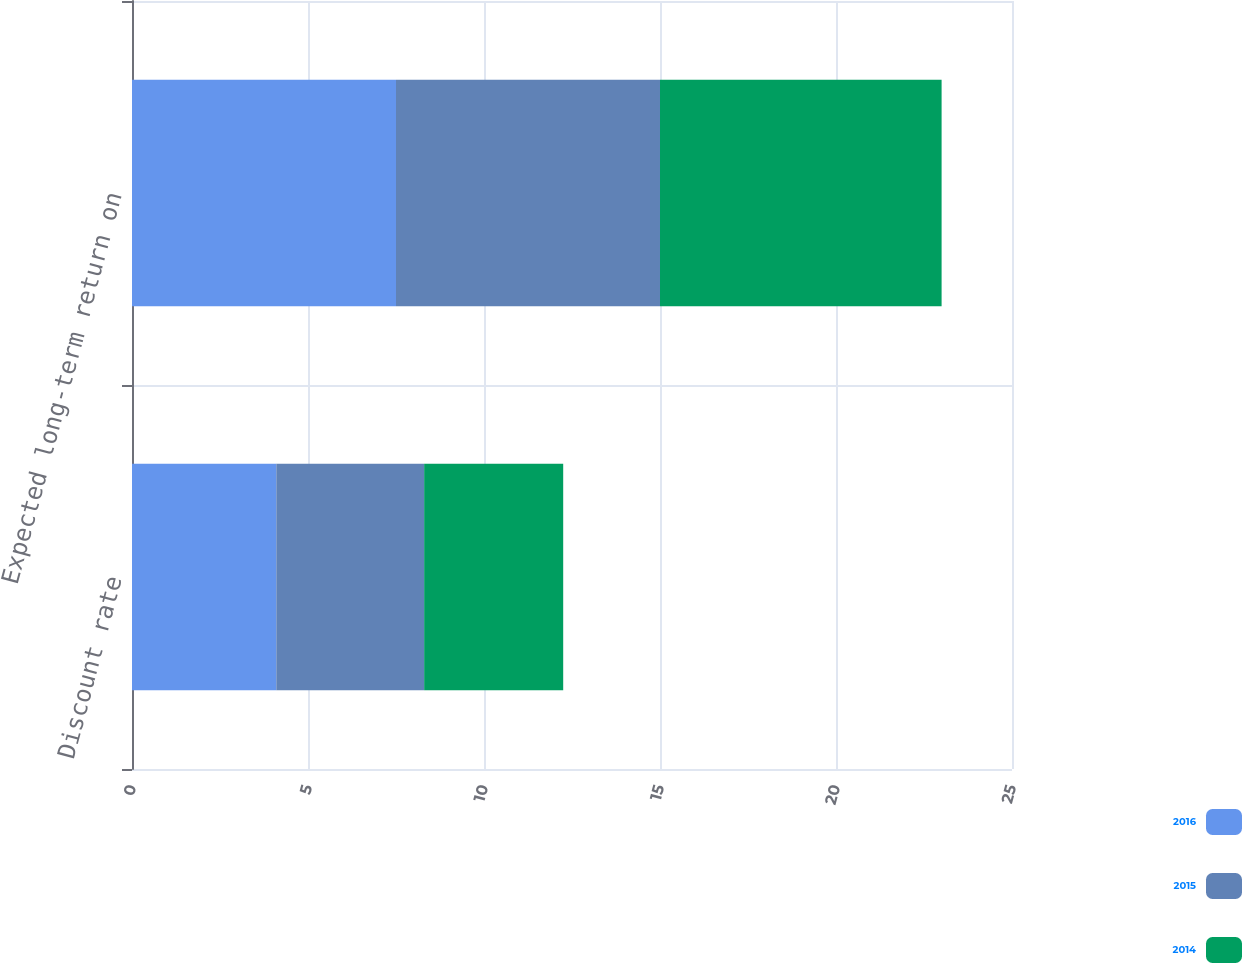Convert chart. <chart><loc_0><loc_0><loc_500><loc_500><stacked_bar_chart><ecel><fcel>Discount rate<fcel>Expected long-term return on<nl><fcel>2016<fcel>4.1<fcel>7.5<nl><fcel>2015<fcel>4.2<fcel>7.5<nl><fcel>2014<fcel>3.95<fcel>8<nl></chart> 